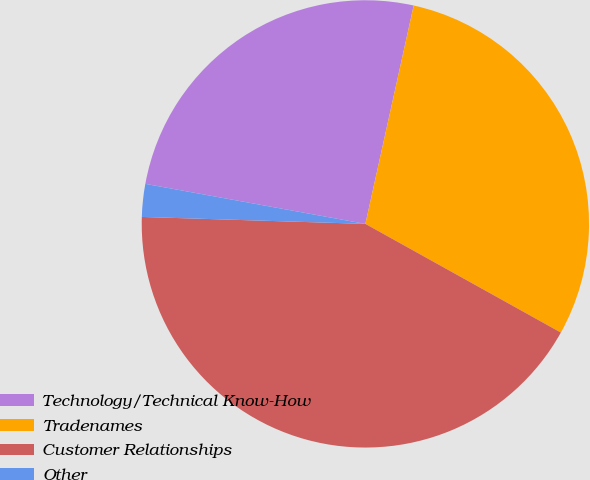Convert chart to OTSL. <chart><loc_0><loc_0><loc_500><loc_500><pie_chart><fcel>Technology/Technical Know-How<fcel>Tradenames<fcel>Customer Relationships<fcel>Other<nl><fcel>25.6%<fcel>29.61%<fcel>42.42%<fcel>2.37%<nl></chart> 